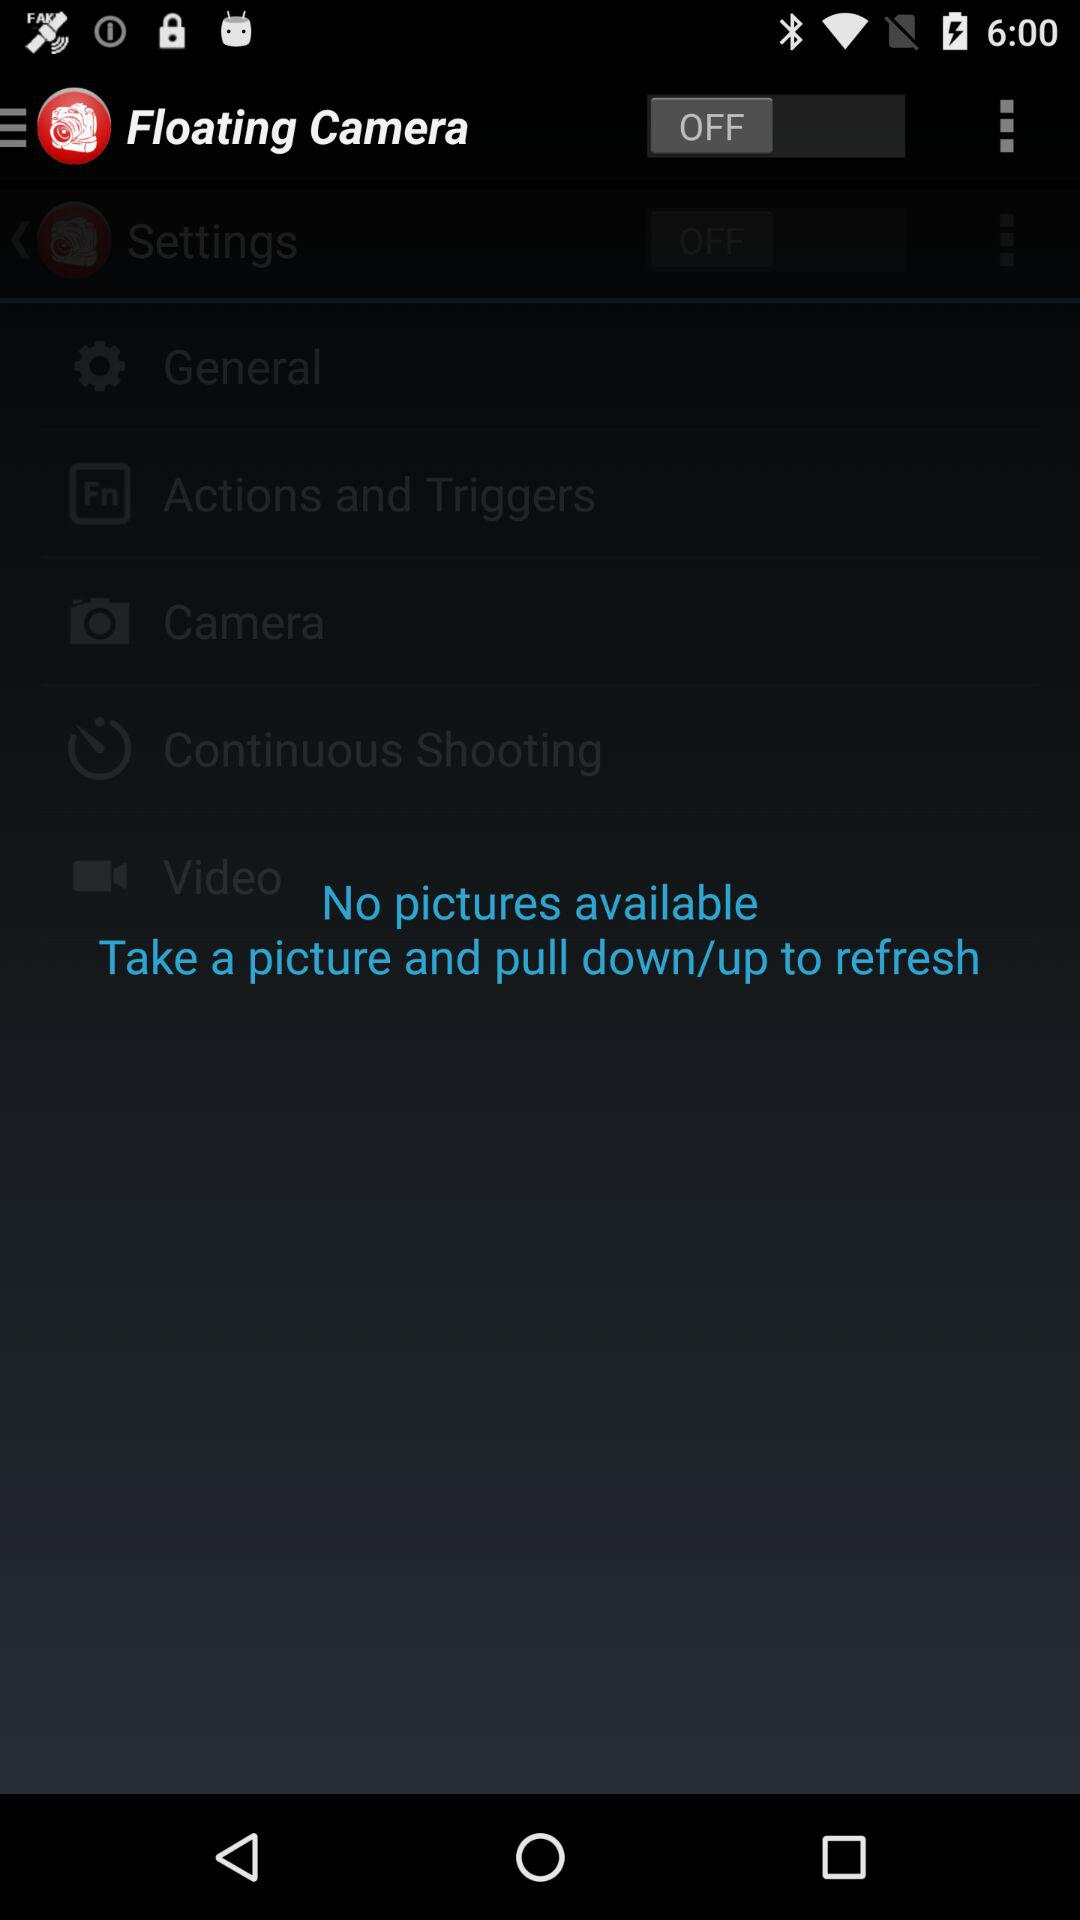What is the name of the application? The name of the application is "Floating Camera". 